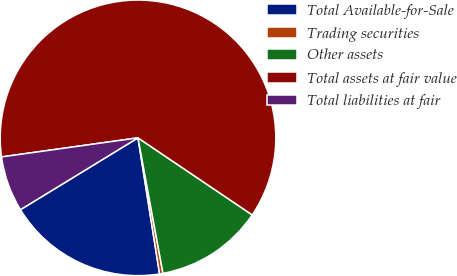<chart> <loc_0><loc_0><loc_500><loc_500><pie_chart><fcel>Total Available-for-Sale<fcel>Trading securities<fcel>Other assets<fcel>Total assets at fair value<fcel>Total liabilities at fair<nl><fcel>18.77%<fcel>0.4%<fcel>12.65%<fcel>61.65%<fcel>6.52%<nl></chart> 